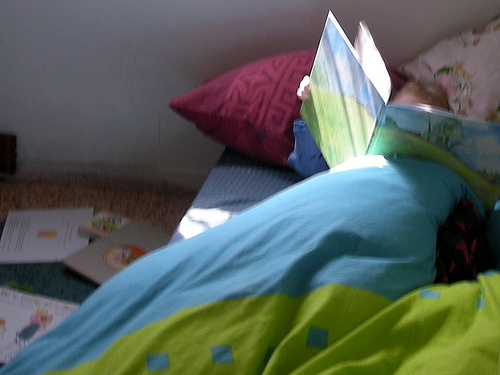Describe the objects in this image and their specific colors. I can see bed in gray, darkgreen, black, and blue tones, book in gray, ivory, black, and purple tones, people in gray, black, and maroon tones, book in gray and black tones, and book in gray, maroon, and black tones in this image. 